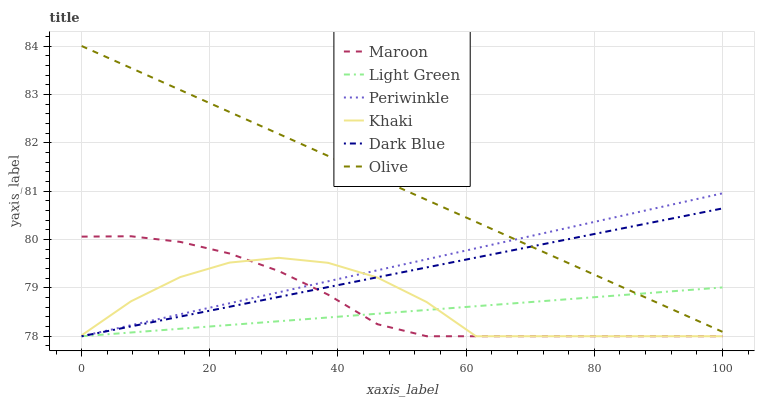Does Light Green have the minimum area under the curve?
Answer yes or no. Yes. Does Olive have the maximum area under the curve?
Answer yes or no. Yes. Does Maroon have the minimum area under the curve?
Answer yes or no. No. Does Maroon have the maximum area under the curve?
Answer yes or no. No. Is Light Green the smoothest?
Answer yes or no. Yes. Is Khaki the roughest?
Answer yes or no. Yes. Is Maroon the smoothest?
Answer yes or no. No. Is Maroon the roughest?
Answer yes or no. No. Does Khaki have the lowest value?
Answer yes or no. Yes. Does Olive have the lowest value?
Answer yes or no. No. Does Olive have the highest value?
Answer yes or no. Yes. Does Maroon have the highest value?
Answer yes or no. No. Is Khaki less than Olive?
Answer yes or no. Yes. Is Olive greater than Khaki?
Answer yes or no. Yes. Does Maroon intersect Periwinkle?
Answer yes or no. Yes. Is Maroon less than Periwinkle?
Answer yes or no. No. Is Maroon greater than Periwinkle?
Answer yes or no. No. Does Khaki intersect Olive?
Answer yes or no. No. 